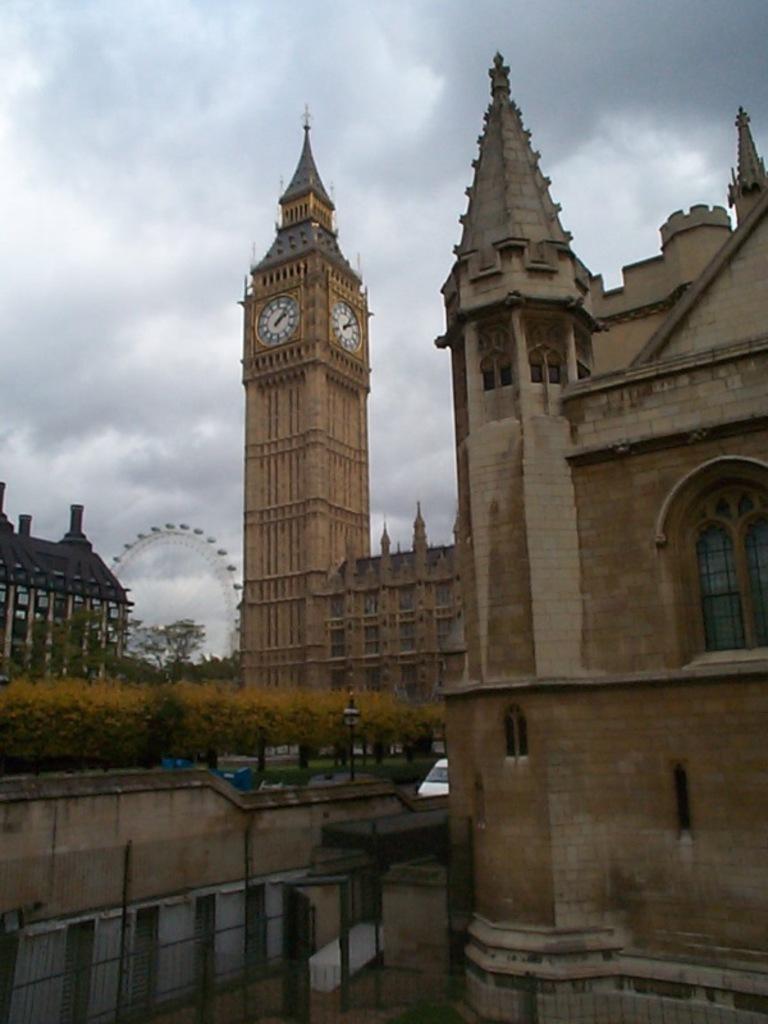In one or two sentences, can you explain what this image depicts? In this image I can see buildings. There is a clock tower, ferris wheel , fencing and there are trees. In the background there is sky. 